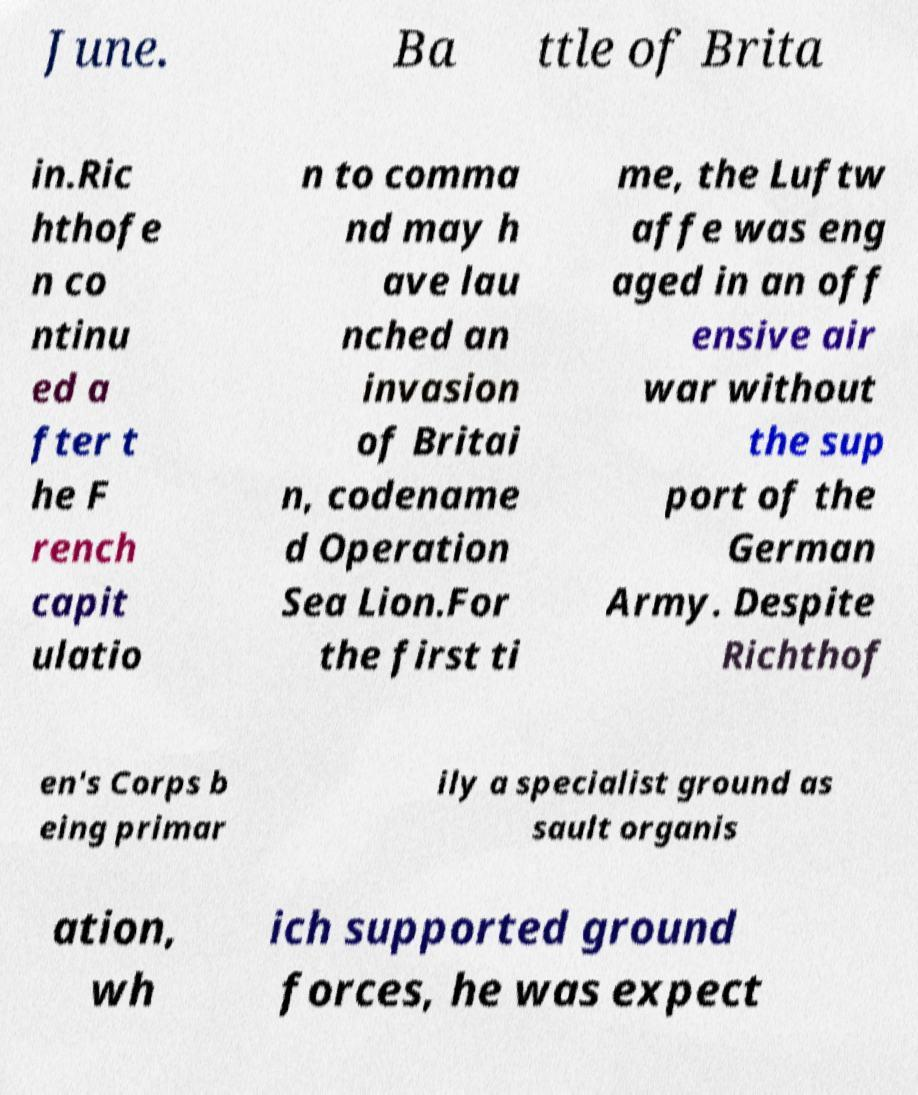Please read and relay the text visible in this image. What does it say? June. Ba ttle of Brita in.Ric hthofe n co ntinu ed a fter t he F rench capit ulatio n to comma nd may h ave lau nched an invasion of Britai n, codename d Operation Sea Lion.For the first ti me, the Luftw affe was eng aged in an off ensive air war without the sup port of the German Army. Despite Richthof en's Corps b eing primar ily a specialist ground as sault organis ation, wh ich supported ground forces, he was expect 